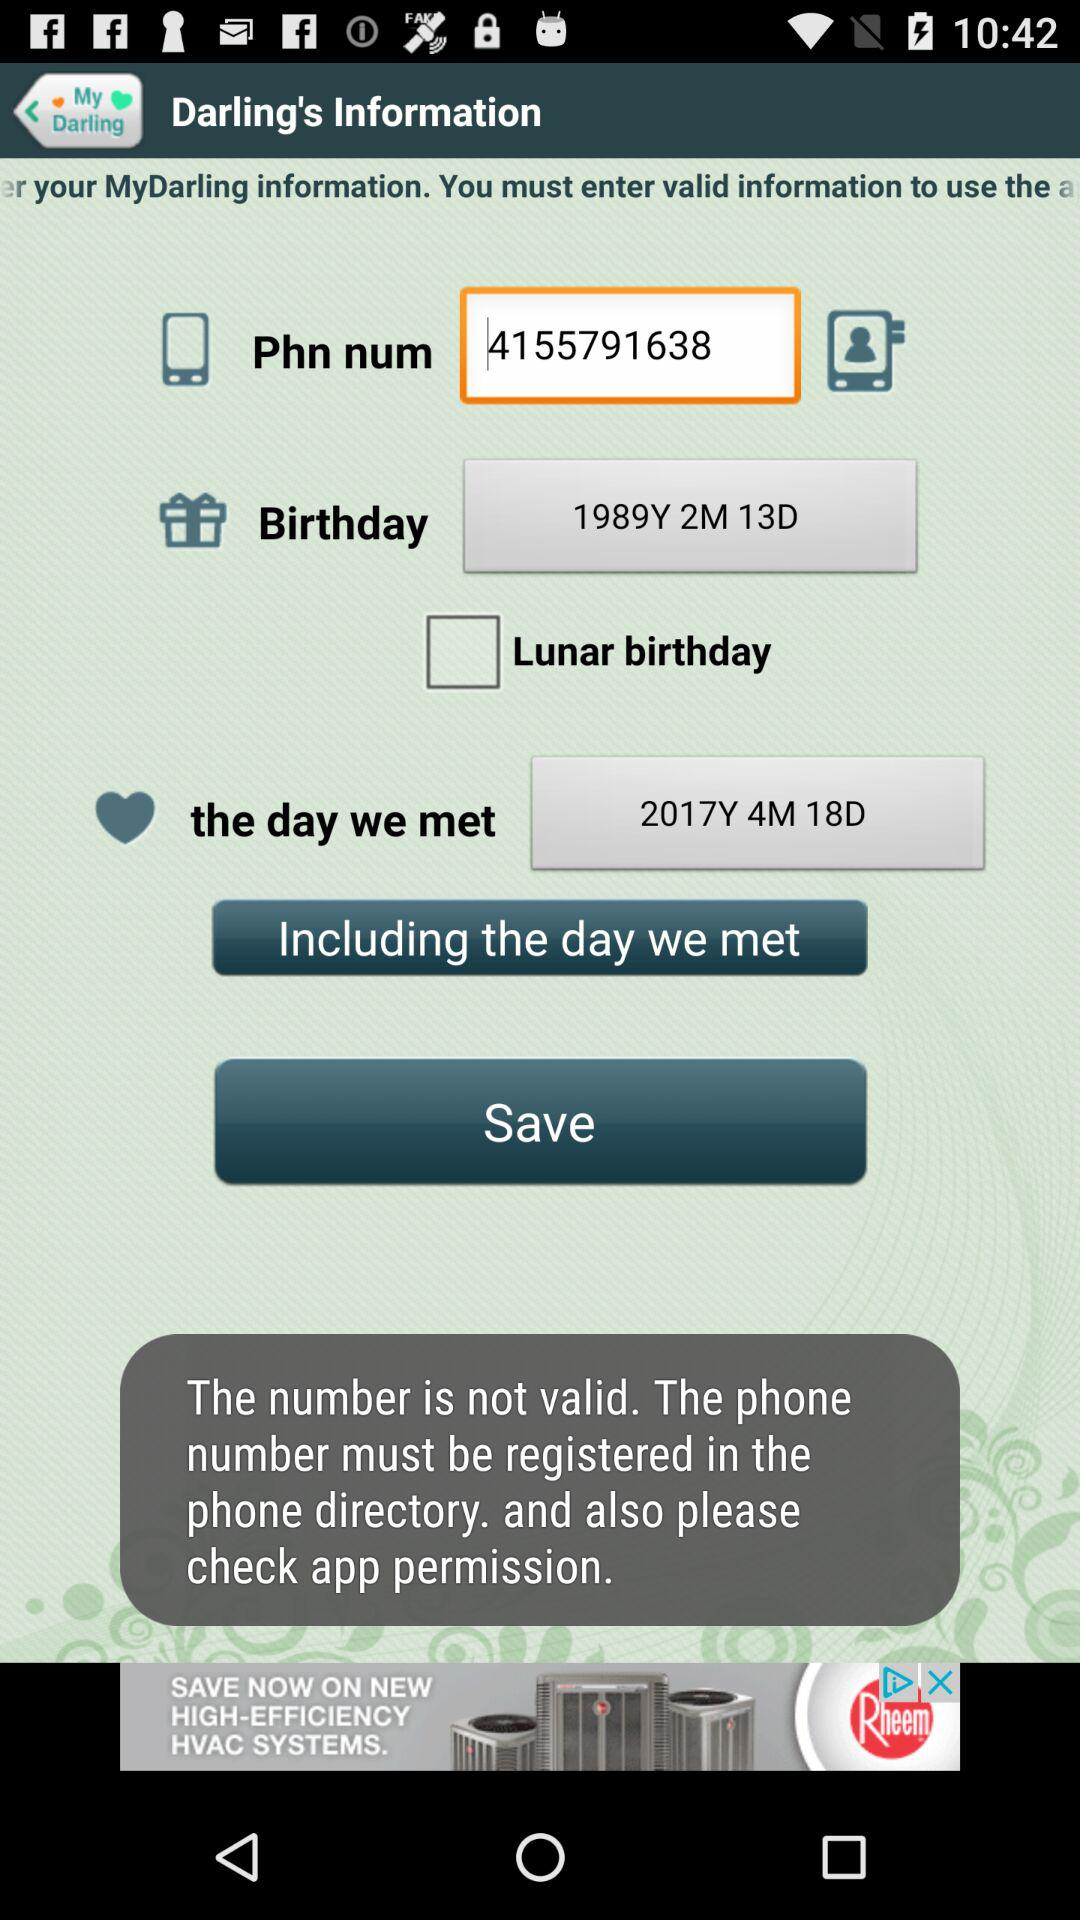What's the phone number? The phone number is 4155791638. 